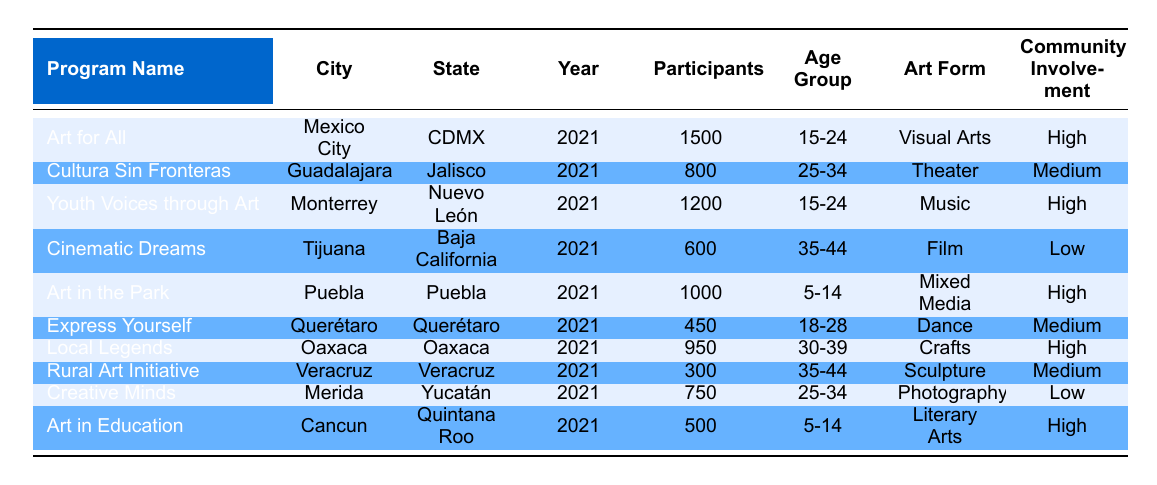What is the program with the highest number of participants? The table lists all the community art programs along with their participant counts. By comparing the participants in each program, "Art for All" in Mexico City has 1500 participants, which is the highest.
Answer: Art for All How many participants are involved in the "Youth Voices through Art" program? The table directly shows that the "Youth Voices through Art" program has 1200 participants listed under the participants column.
Answer: 1200 Is there any program that focuses on "Dance"? By checking the art forms of all programs listed in the table, "Express Yourself" in Querétaro is the only program that focuses on Dance.
Answer: Yes What is the total number of participants in all programs categorized as "High" community involvement? First, we identify the programs with "High" community involvement: "Art for All" (1500), "Youth Voices through Art" (1200), "Art in the Park" (1000), "Local Legends" (950), and "Art in Education" (500). Then, we add their participant counts: 1500 + 1200 + 1000 + 950 + 500 = 4150.
Answer: 4150 Which age group has the least number of participants across all programs? The participants in different age groups include: "5-14" (1000 + 500 = 1500), "15-24" (1500 + 1200 = 2700), "25-34" (800 + 750 = 1550), "35-44" (600 + 300 = 900), "30-39" (950). The age group "35-44" has the least total participants with 900.
Answer: 35-44 How many programs are there in the state of Jalisco, and what are their names? The table shows two programs in Jalisco: "Cultura Sin Fronteras" and there is only one program in that state.
Answer: 1, Cultura Sin Fronteras Are there any programs focused on "Film" that involve "High" community involvement? The program "Cinematic Dreams" is focused on Film, but it has "Low" community involvement. Therefore, there are no programs of this type with "High" community involvement.
Answer: No What is the average number of participants in programs focused on "Mixed Media"? There is only one program focused on "Mixed Media," which is "Art in the Park" with 1000 participants. Since there's only one program, the average is the same as that number: 1000.
Answer: 1000 